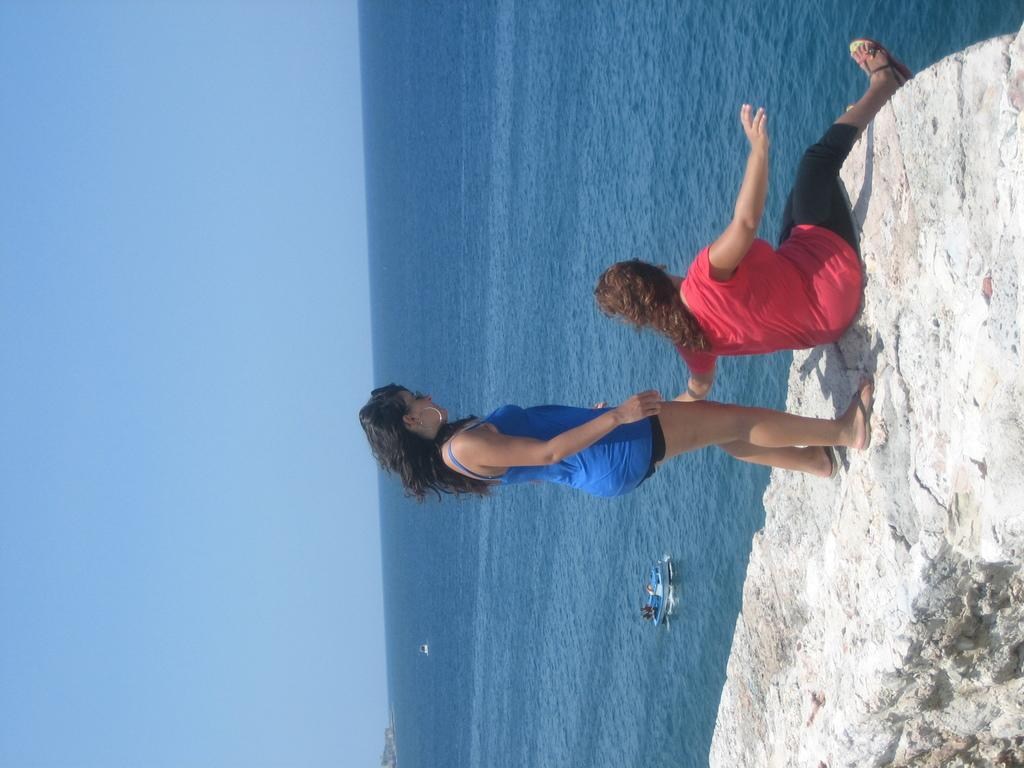What are the women in the image wearing? There is a woman wearing a blue dress and another woman wearing a pink t-shirt and black pants in the image. What is the position of the women in the image? Both women are on the ground in the image. What can be seen in the background of the image? There is water, a boat, and the sky visible in the background of the image. Can you hear the sound of the mitten in the image? There is no mitten present in the image, and therefore no sound associated with it. 